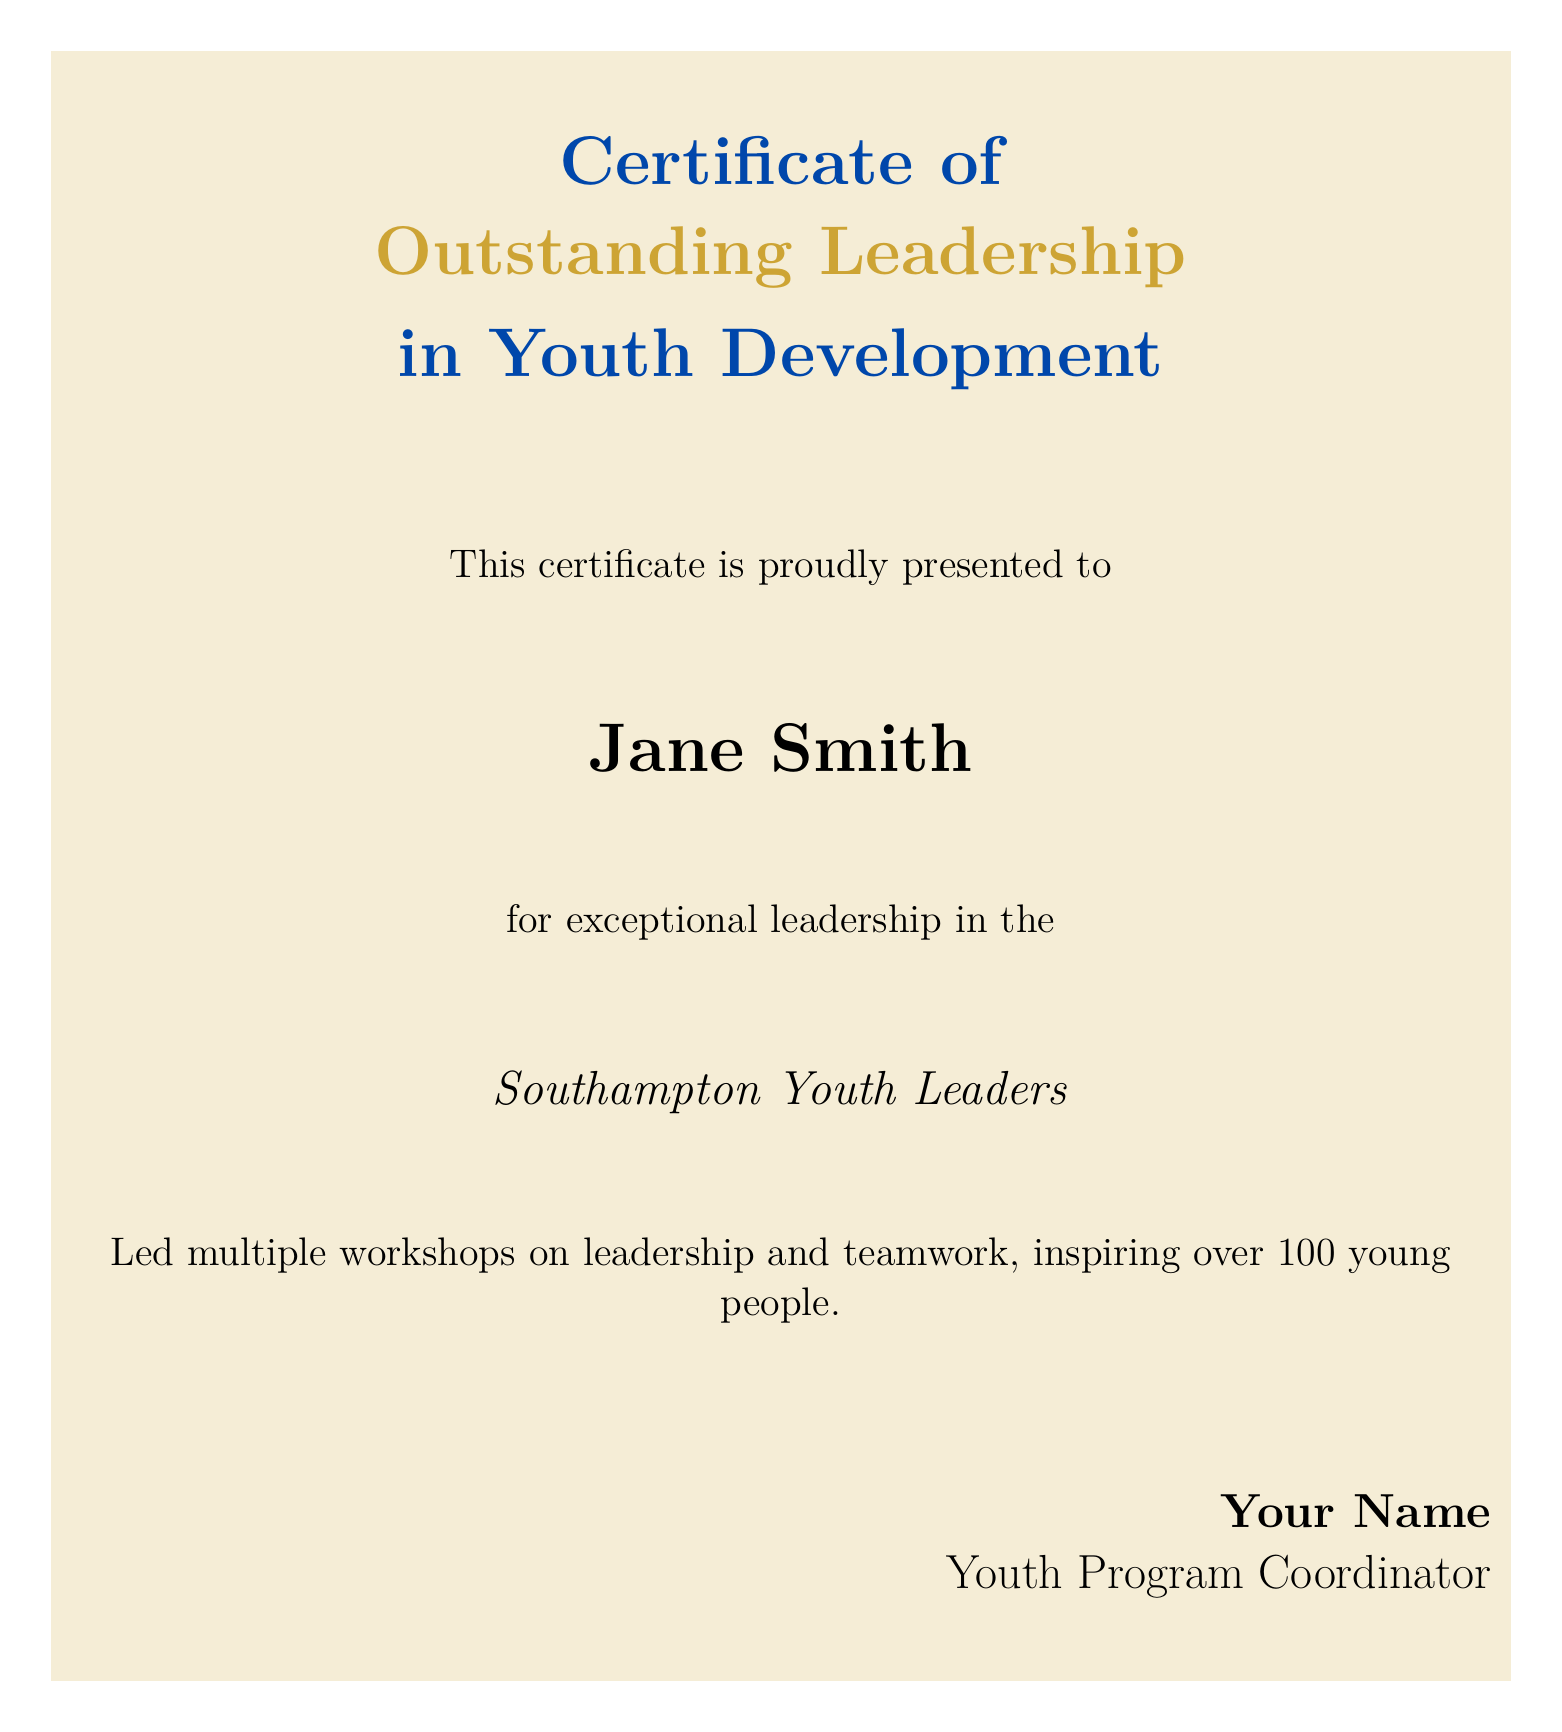What is the title of the certificate? The title is displayed prominently in the certificate layout, indicating the purpose of the certificate.
Answer: Outstanding Leadership in Youth Development Who is the recipient of the certificate? The recipient's name is highlighted in a large bold font within the certificate design.
Answer: Jane Smith What organization is associated with the certificate? The organization is mentioned alongside the recipient's name, specifying where the leadership was demonstrated.
Answer: Southampton Youth Leaders How many young people were inspired by the recipient? The number is included in the description of the recipient's achievements on the certificate.
Answer: Over 100 What is the name of the issuer of the certificate? The issuer's name appears in a designated area at the bottom of the certificate, signifying who is presenting it.
Answer: Your Name What is the overall color theme of the certificate? The color theme can be inferred from the highlights and backgrounds throughout the certificate.
Answer: Golden and blue What type of award does this certificate represent? The type of recognition is indicated in the title of the certificate, defining its purpose.
Answer: Leadership award What kind of activities did the recipient lead? The specific activities led by the recipient are outlined in the certificate, showcasing their contributions.
Answer: Workshops on leadership and teamwork 